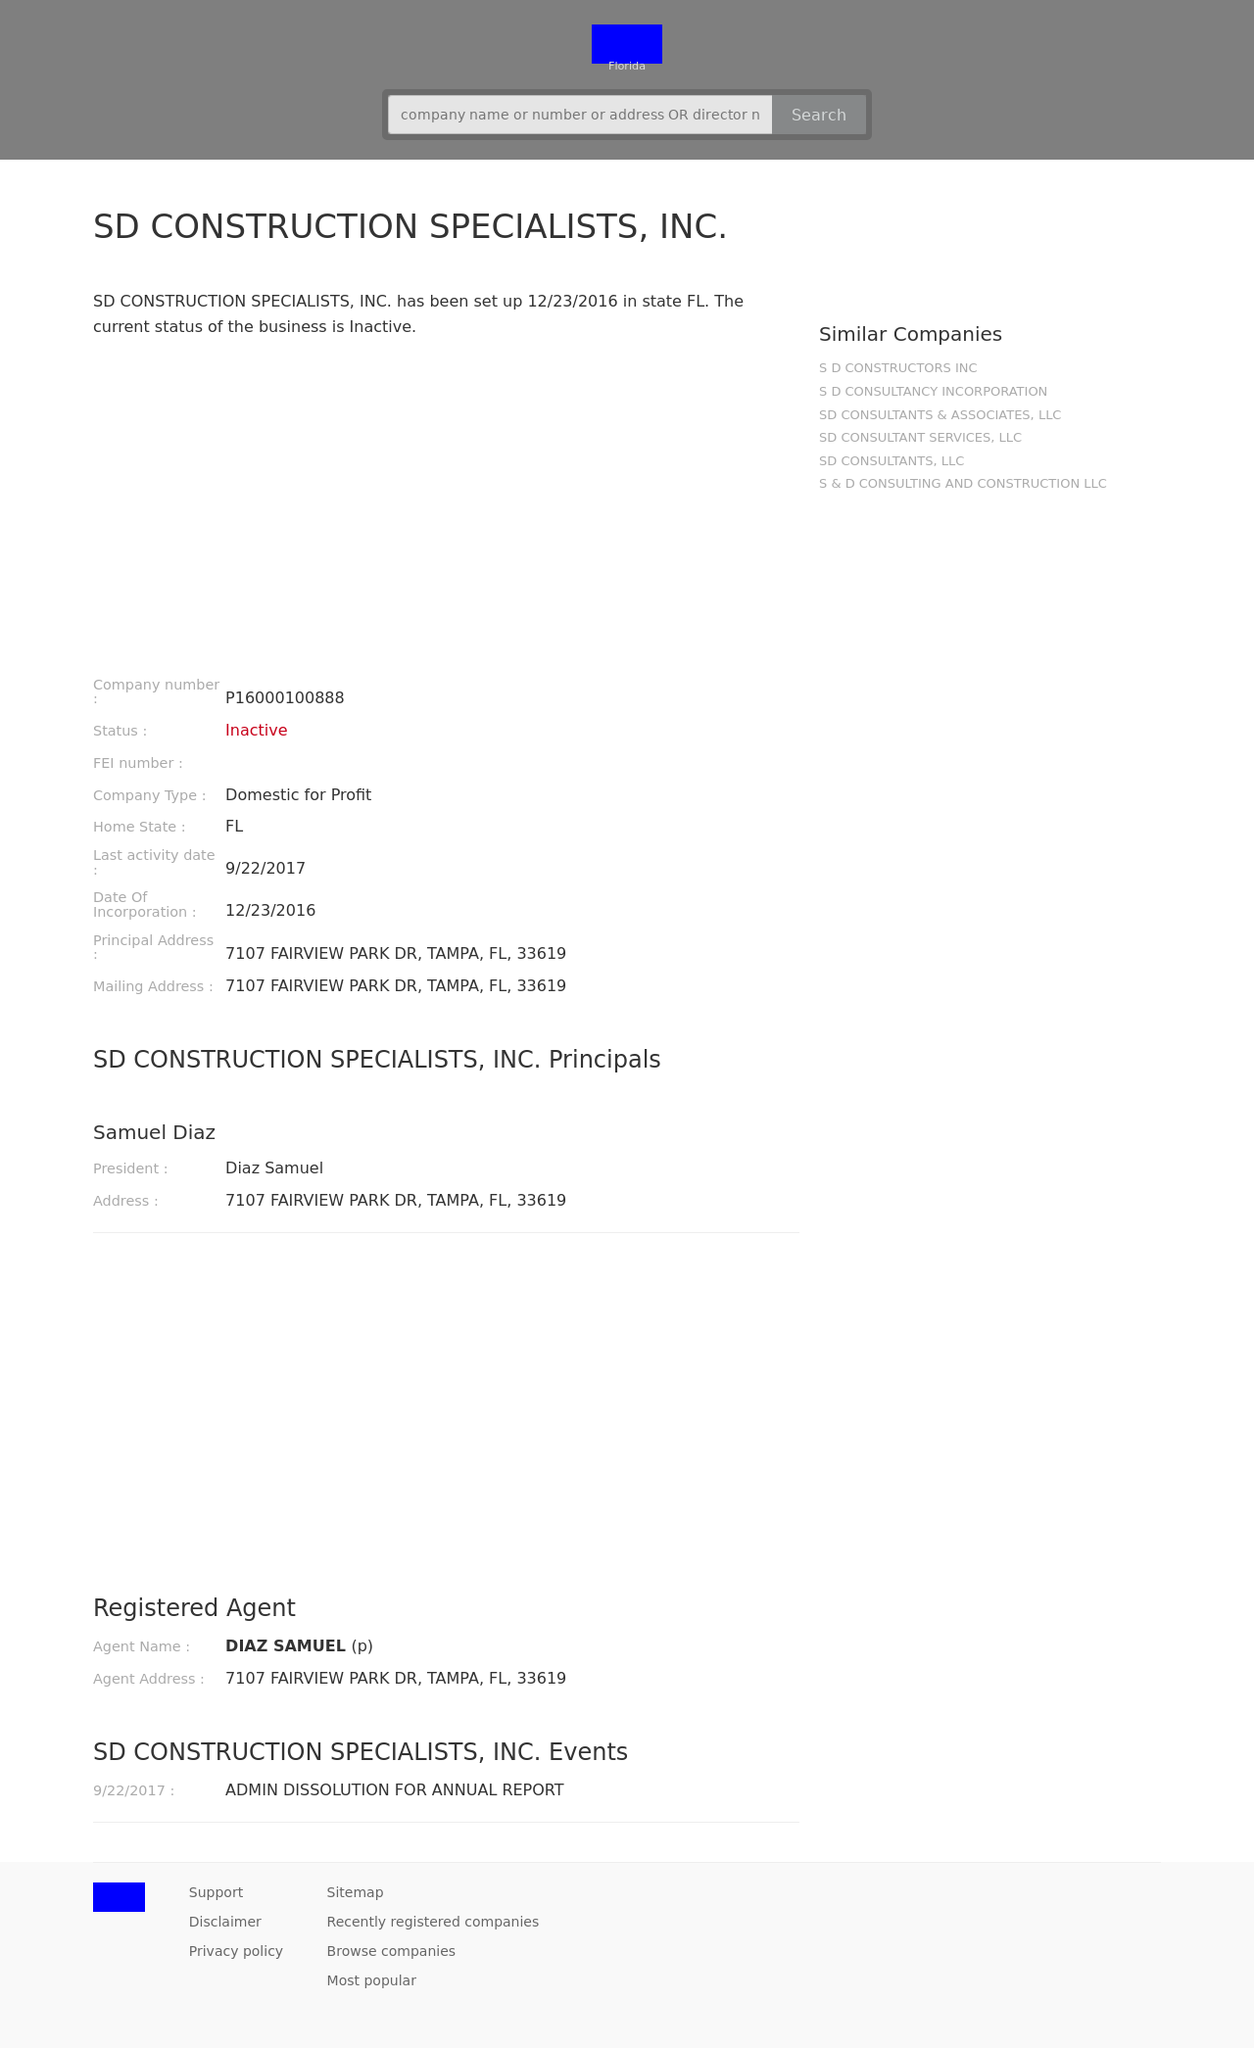How can I start building this website with HTML from the ground up? To begin building a website similar to the one depicted in the image using HTML, start with a basic structure outlining the HTML, head, and body tags. Within the body, define your content sections such as headers, footers, main article area, and any side panels or navigation bars. Each section can be labeled with comments for better understanding and maintenance. It's also beneficial to use separate CSS files for styling and JavaScript files for functionalities. This approach will help you structure and manage your website's development more efficiently. 